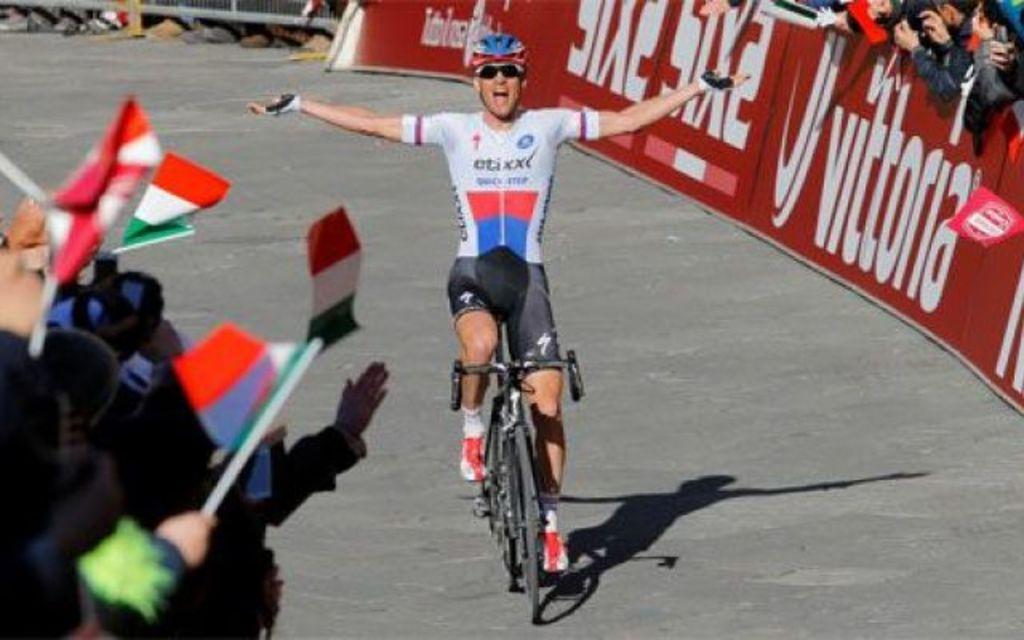Can you describe this image briefly? In the image we can see there is a man sitting on the bicycle and he is wearing helmet. There are people standing and they are holding flags in their hands. There is banner kept on the road. 